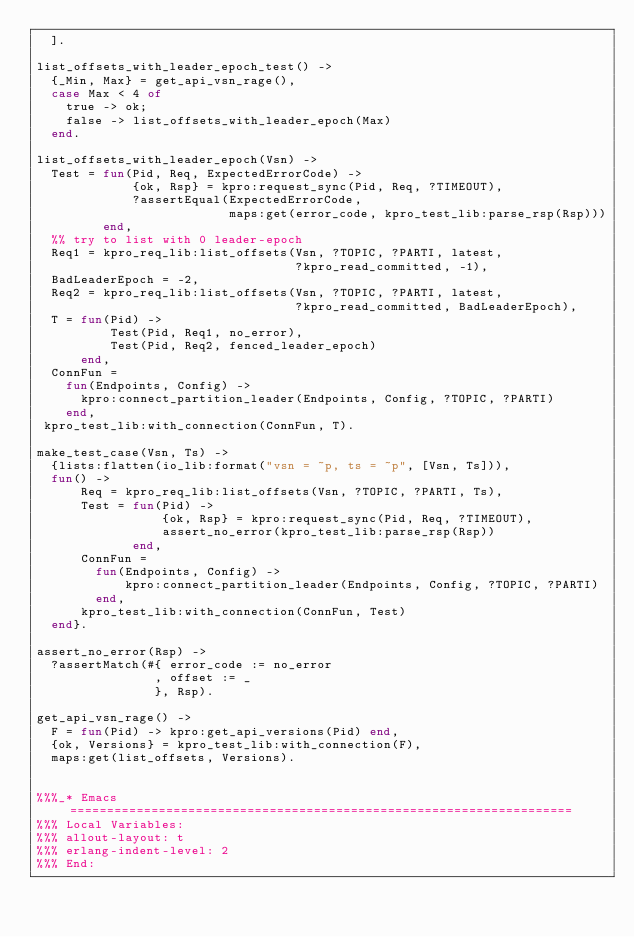Convert code to text. <code><loc_0><loc_0><loc_500><loc_500><_Erlang_>  ].

list_offsets_with_leader_epoch_test() ->
  {_Min, Max} = get_api_vsn_rage(),
  case Max < 4 of
    true -> ok;
    false -> list_offsets_with_leader_epoch(Max)
  end.

list_offsets_with_leader_epoch(Vsn) ->
  Test = fun(Pid, Req, ExpectedErrorCode) ->
             {ok, Rsp} = kpro:request_sync(Pid, Req, ?TIMEOUT),
             ?assertEqual(ExpectedErrorCode,
                          maps:get(error_code, kpro_test_lib:parse_rsp(Rsp)))
         end,
  %% try to list with 0 leader-epoch
  Req1 = kpro_req_lib:list_offsets(Vsn, ?TOPIC, ?PARTI, latest,
                                   ?kpro_read_committed, -1),
  BadLeaderEpoch = -2,
  Req2 = kpro_req_lib:list_offsets(Vsn, ?TOPIC, ?PARTI, latest,
                                   ?kpro_read_committed, BadLeaderEpoch),
  T = fun(Pid) ->
          Test(Pid, Req1, no_error),
          Test(Pid, Req2, fenced_leader_epoch)
      end,
  ConnFun =
    fun(Endpoints, Config) ->
      kpro:connect_partition_leader(Endpoints, Config, ?TOPIC, ?PARTI)
    end,
 kpro_test_lib:with_connection(ConnFun, T).

make_test_case(Vsn, Ts) ->
  {lists:flatten(io_lib:format("vsn = ~p, ts = ~p", [Vsn, Ts])),
  fun() ->
      Req = kpro_req_lib:list_offsets(Vsn, ?TOPIC, ?PARTI, Ts),
      Test = fun(Pid) ->
                 {ok, Rsp} = kpro:request_sync(Pid, Req, ?TIMEOUT),
                 assert_no_error(kpro_test_lib:parse_rsp(Rsp))
             end,
      ConnFun =
        fun(Endpoints, Config) ->
            kpro:connect_partition_leader(Endpoints, Config, ?TOPIC, ?PARTI)
        end,
      kpro_test_lib:with_connection(ConnFun, Test)
  end}.

assert_no_error(Rsp) ->
  ?assertMatch(#{ error_code := no_error
                , offset := _
                }, Rsp).

get_api_vsn_rage() ->
  F = fun(Pid) -> kpro:get_api_versions(Pid) end,
  {ok, Versions} = kpro_test_lib:with_connection(F),
  maps:get(list_offsets, Versions).


%%%_* Emacs ====================================================================
%%% Local Variables:
%%% allout-layout: t
%%% erlang-indent-level: 2
%%% End:
</code> 